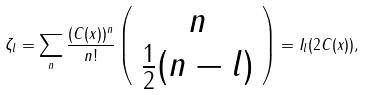Convert formula to latex. <formula><loc_0><loc_0><loc_500><loc_500>\zeta _ { l } = \sum _ { n } \frac { ( C ( x ) ) ^ { n } } { n ! } \left ( \begin{array} { c } n \\ \frac { 1 } { 2 } ( n - l ) \\ \end{array} \right ) = I _ { l } ( 2 C ( x ) ) ,</formula> 